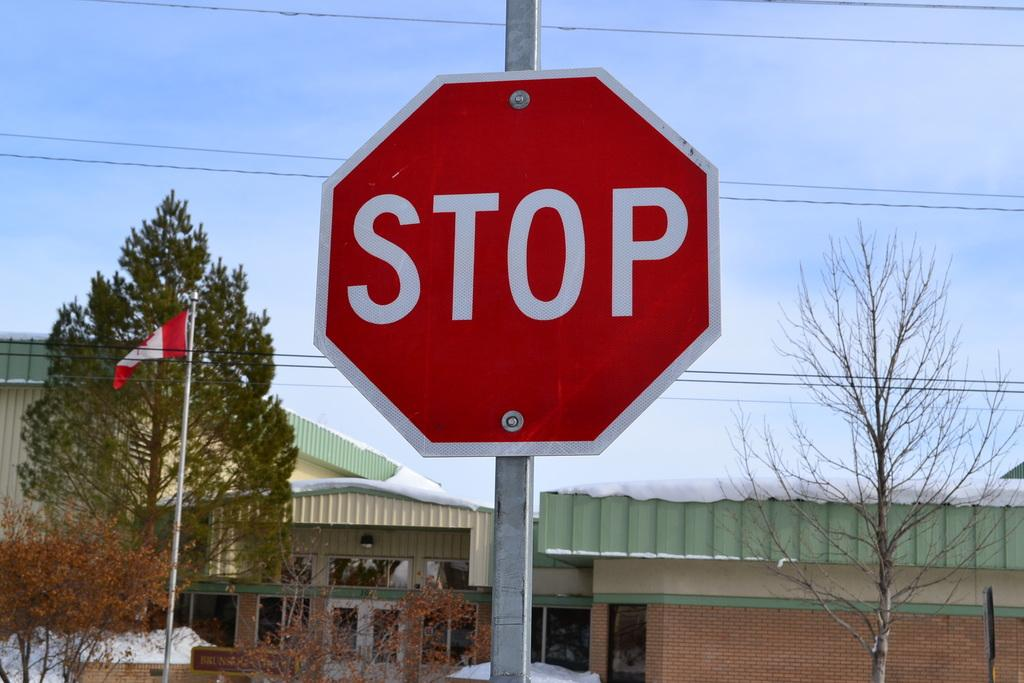<image>
Describe the image concisely. A stop sign against a bright blue sky in Canada. 